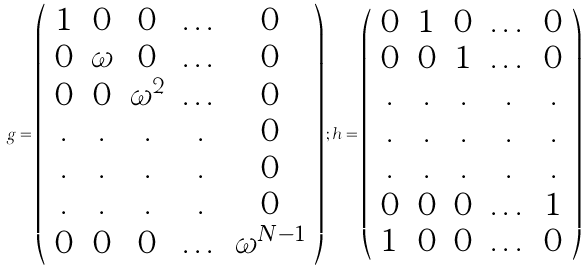<formula> <loc_0><loc_0><loc_500><loc_500>g = \left ( \begin{array} { c c c c c } 1 & 0 & 0 & \dots & 0 \\ 0 & \omega & 0 & \dots & 0 \\ 0 & 0 & \omega ^ { 2 } & \dots & 0 \\ . & . & . & . & 0 \\ . & . & . & . & 0 \\ . & . & . & . & 0 \\ 0 & 0 & 0 & \dots & \omega ^ { N - 1 } \end{array} \right ) ; h = \left ( \begin{array} { c c c c c } 0 & 1 & 0 & \dots & 0 \\ 0 & 0 & 1 & \dots & 0 \\ . & . & . & . & . \\ . & . & . & . & . \\ . & . & . & . & . \\ 0 & 0 & 0 & \dots & 1 \\ 1 & 0 & 0 & \dots & 0 \end{array} \right )</formula> 